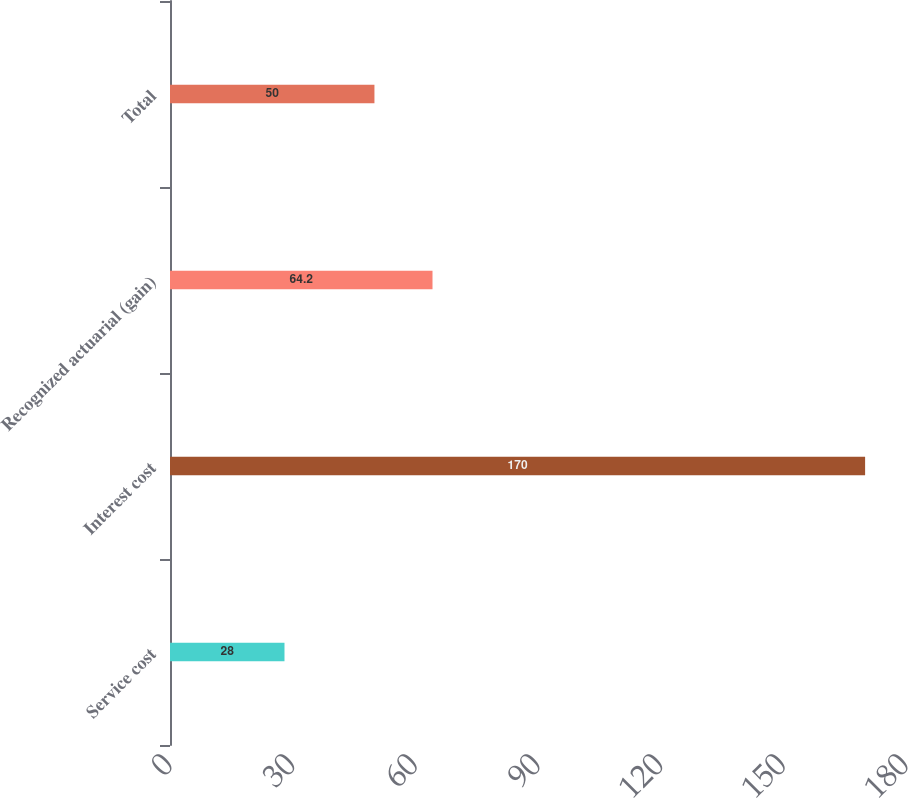Convert chart to OTSL. <chart><loc_0><loc_0><loc_500><loc_500><bar_chart><fcel>Service cost<fcel>Interest cost<fcel>Recognized actuarial (gain)<fcel>Total<nl><fcel>28<fcel>170<fcel>64.2<fcel>50<nl></chart> 